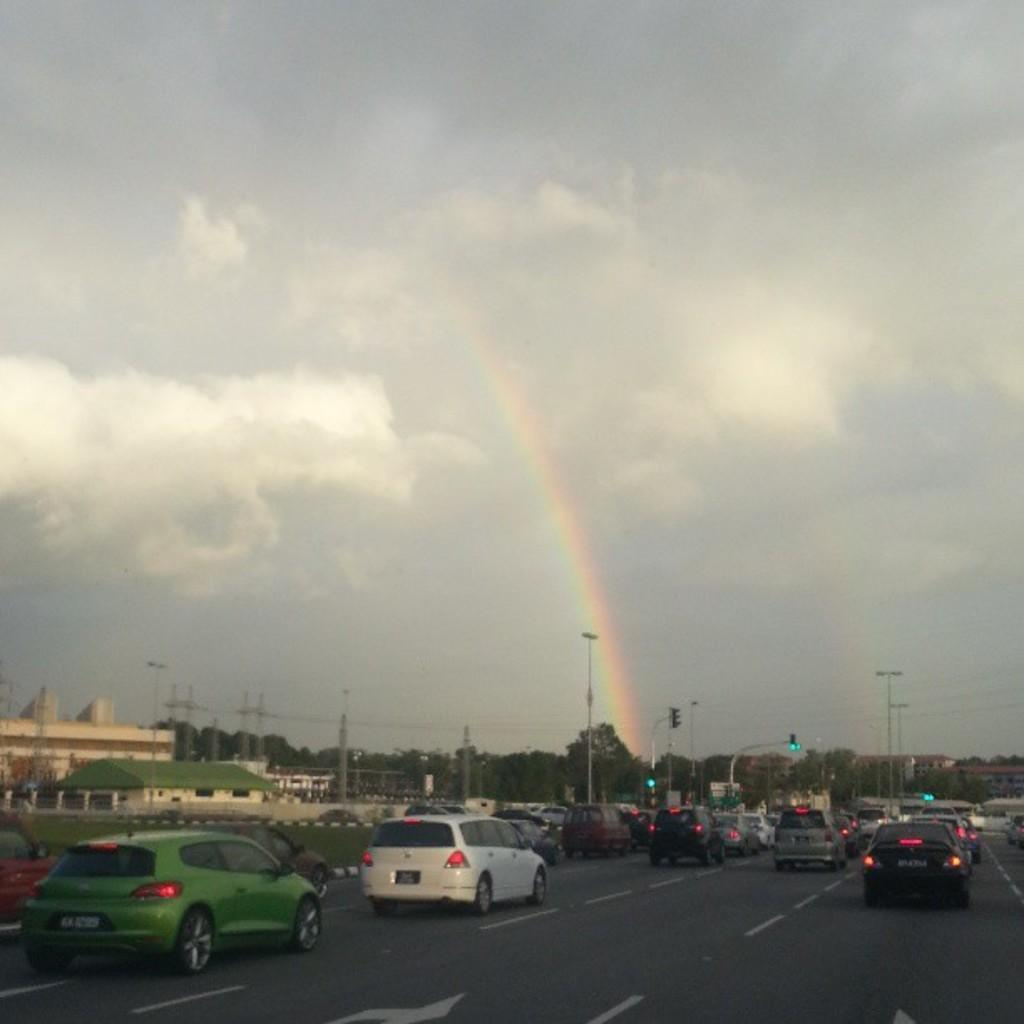What is happening on the road in the image? There are cars moving on the road in the image. What can be seen in the background of the image? There are trees in the background of the image. What natural phenomenon is visible in the sky? There is a rainbow visible in the sky. What else can be seen in the sky? There are clouds in the sky. What type of pot is being used to recite a verse in the image? There is no pot or verse present in the image; it features cars moving on the road, trees in the background, and a rainbow in the sky. 